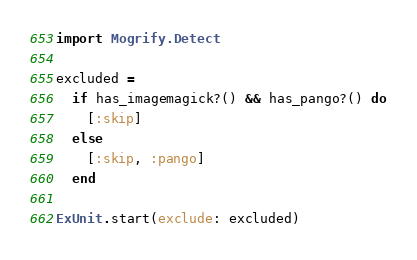<code> <loc_0><loc_0><loc_500><loc_500><_Elixir_>import Mogrify.Detect

excluded =
  if has_imagemagick?() && has_pango?() do
    [:skip]
  else
    [:skip, :pango]
  end

ExUnit.start(exclude: excluded)
</code> 